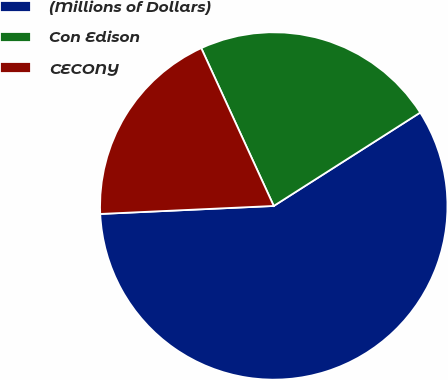<chart> <loc_0><loc_0><loc_500><loc_500><pie_chart><fcel>(Millions of Dollars)<fcel>Con Edison<fcel>CECONY<nl><fcel>58.3%<fcel>22.82%<fcel>18.88%<nl></chart> 